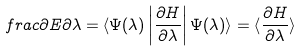Convert formula to latex. <formula><loc_0><loc_0><loc_500><loc_500>\quad f r a c { \partial E } { \partial \lambda } = \langle \Psi ( \lambda ) \left | \frac { \partial H } { \partial \lambda } \right | \Psi ( \lambda ) \rangle = \langle \frac { \partial H } { \partial \lambda } \rangle</formula> 